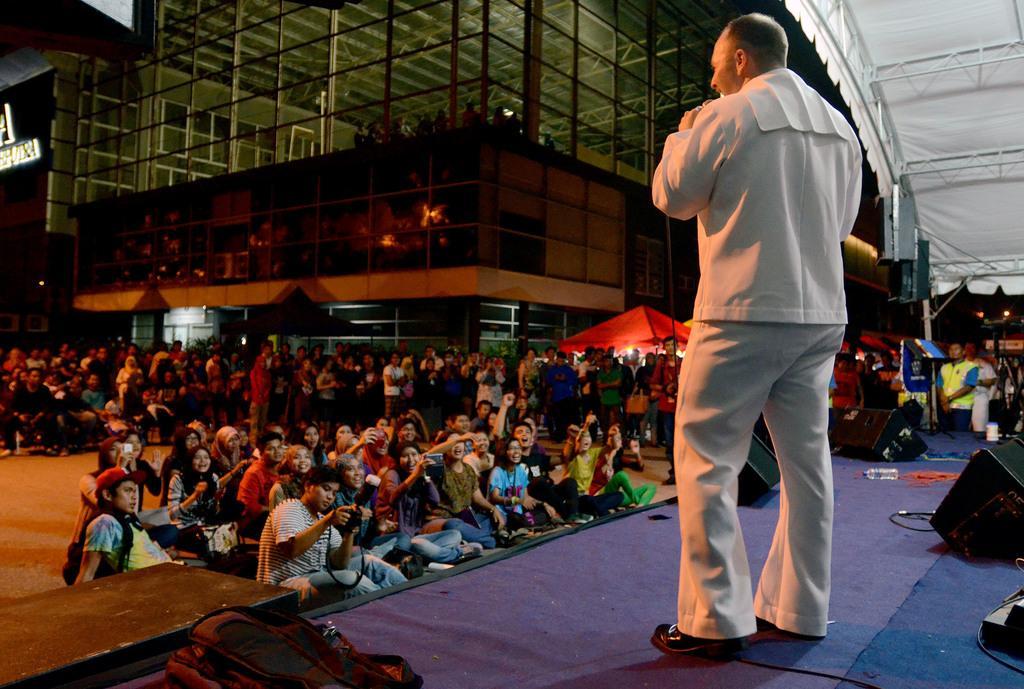Describe this image in one or two sentences. On the right side of the image, we can see a person is standing on the stage. Here we can see few objects and backpack. Background we can see a group of people, stalls, poles, buildings, walls, glass objects, lights and tent. Here we can see few people are sitting on the surface. Few are holding some objects. 